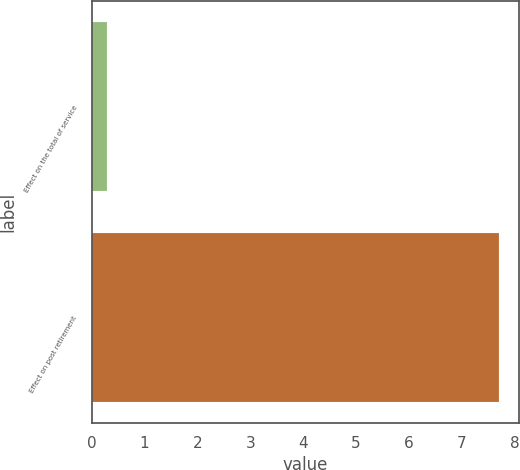<chart> <loc_0><loc_0><loc_500><loc_500><bar_chart><fcel>Effect on the total of service<fcel>Effect on post retirement<nl><fcel>0.3<fcel>7.7<nl></chart> 